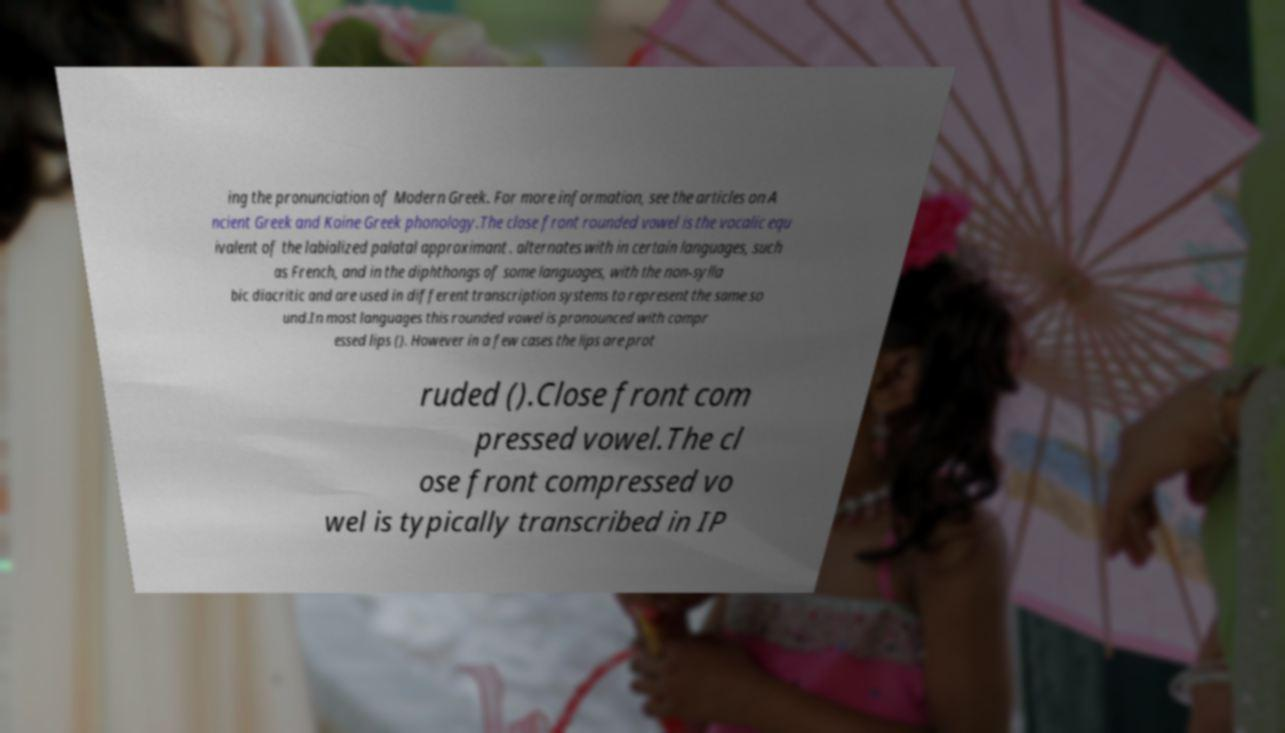For documentation purposes, I need the text within this image transcribed. Could you provide that? ing the pronunciation of Modern Greek. For more information, see the articles on A ncient Greek and Koine Greek phonology.The close front rounded vowel is the vocalic equ ivalent of the labialized palatal approximant . alternates with in certain languages, such as French, and in the diphthongs of some languages, with the non-sylla bic diacritic and are used in different transcription systems to represent the same so und.In most languages this rounded vowel is pronounced with compr essed lips (). However in a few cases the lips are prot ruded ().Close front com pressed vowel.The cl ose front compressed vo wel is typically transcribed in IP 